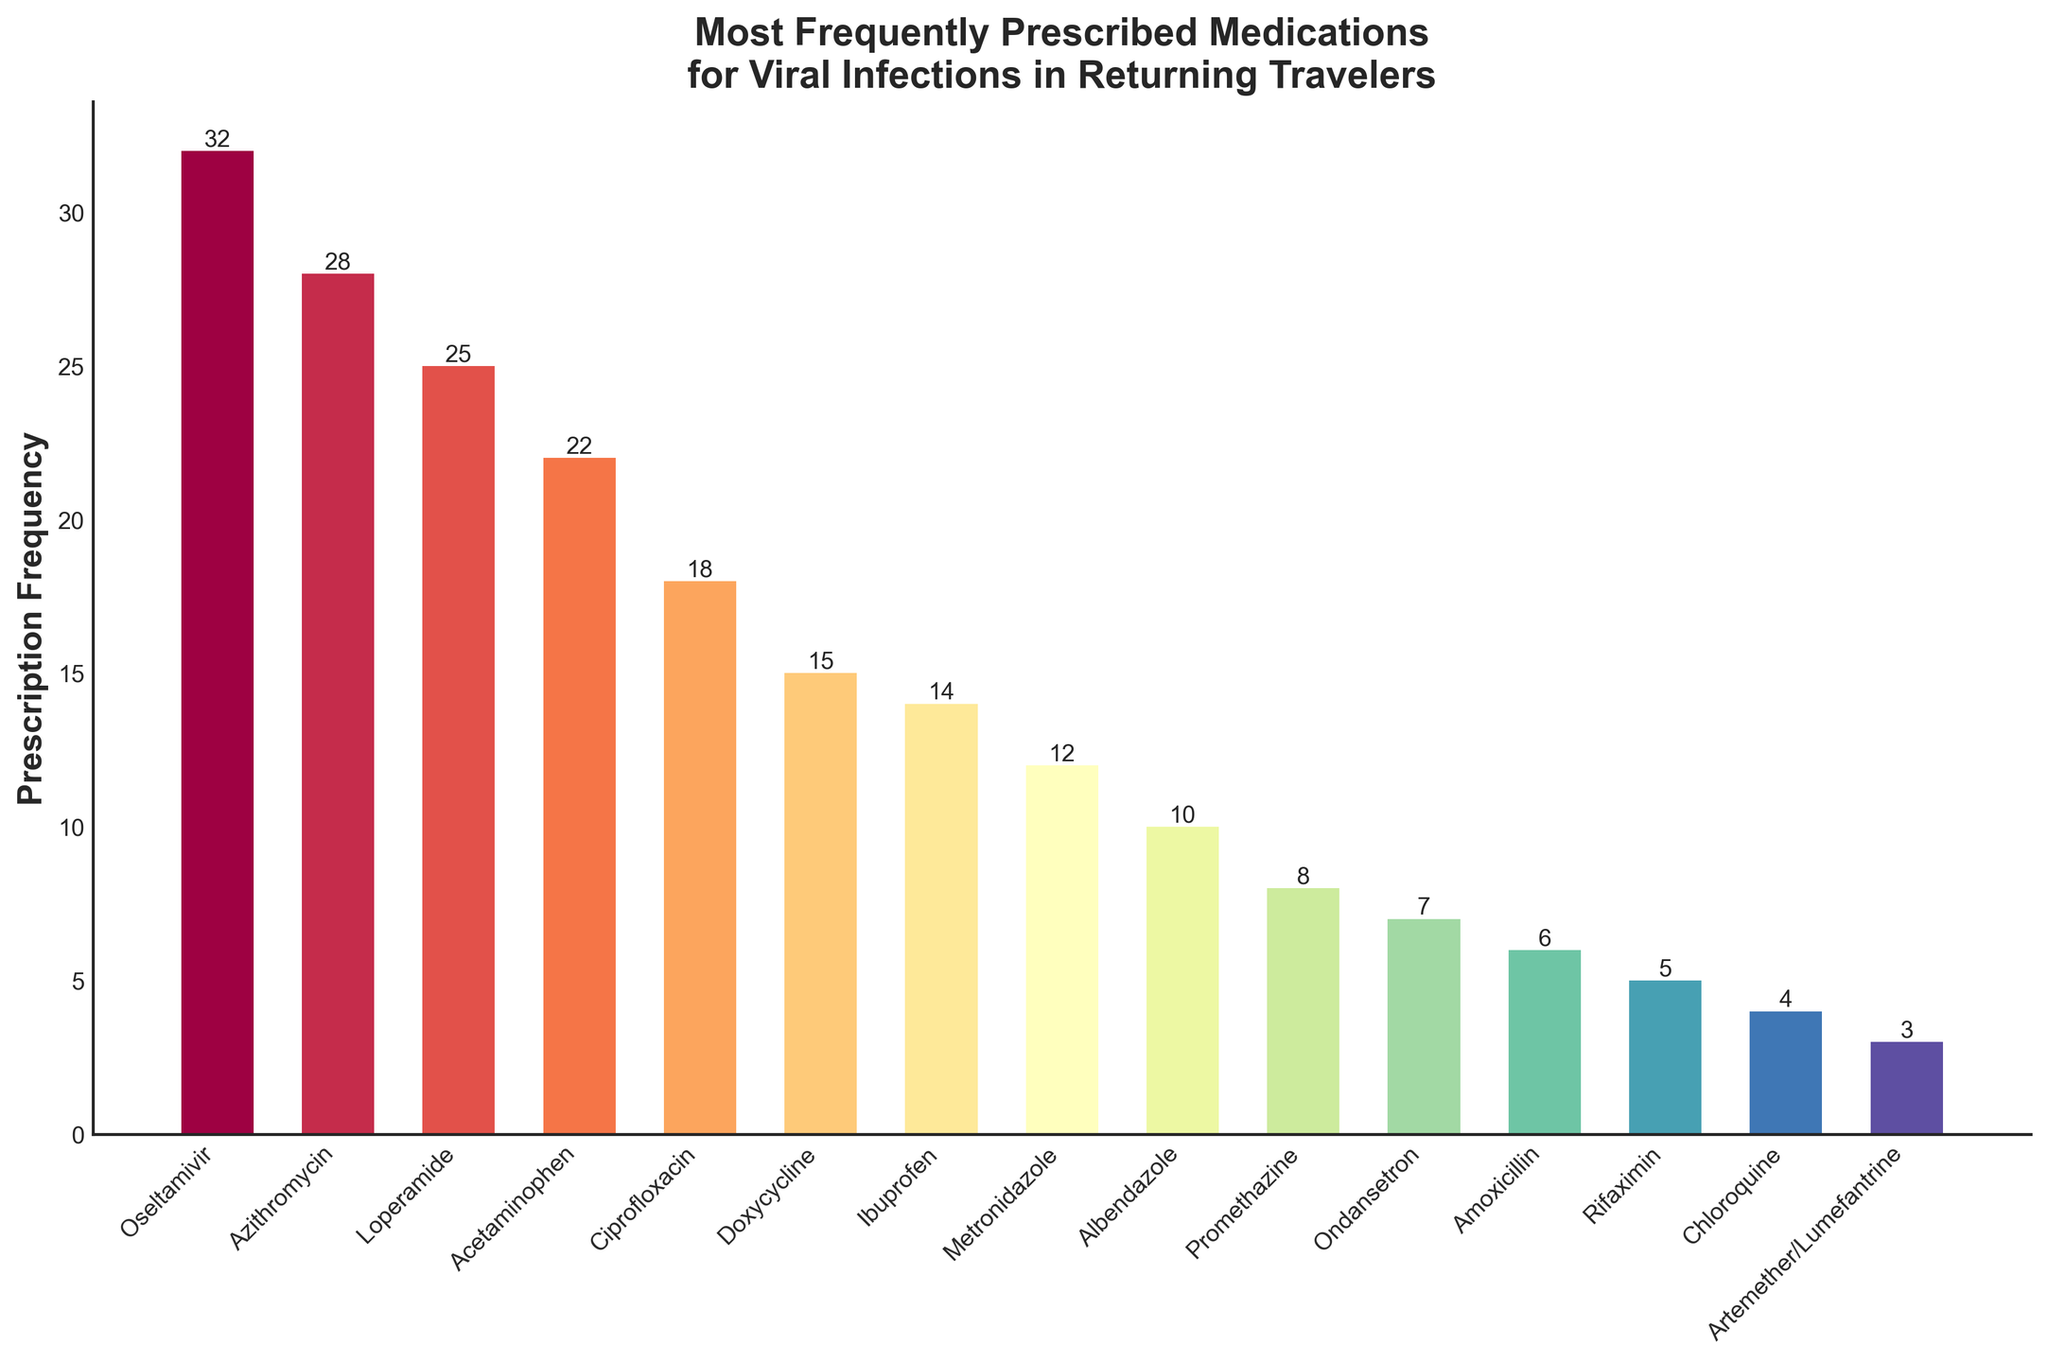Which medication has the highest prescription frequency? Observing the heights of the bars, Oseltamivir has the tallest bar, indicating it has the highest prescription frequency of 32.
Answer: Oseltamivir How many more prescriptions does Oseltamivir have compared to Azithromycin? Oseltamivir has 32 prescriptions and Azithromycin has 28. The difference is 32 - 28 = 4.
Answer: 4 What is the total number of prescriptions for Acetaminophen, Ciprofloxacin, and Doxycycline? Summing up the prescription frequencies: Acetaminophen (22) + Ciprofloxacin (18) + Doxycycline (15) equals 55.
Answer: 55 Which two medications have the smallest prescription frequencies? By examining the height of the bars, Artemether/Lumefantrine (3) and Chloroquine (4) have the smallest frequencies.
Answer: Artemether/Lumefantrine and Chloroquine What is the difference in prescription frequency between Loperamide and Ibuprofen? Loperamide has 25 prescriptions and Ibuprofen has 14. The difference is 25 - 14 = 11.
Answer: 11 Is the prescription frequency of Metronidazole greater than that of Albendazole? Metronidazole has 12 prescriptions while Albendazole has 10. Since 12 > 10, the frequency of Metronidazole is indeed greater.
Answer: Yes Which medication, among Promethazine and Ondansetron, is prescribed more frequently? Promethazine has 8 prescriptions and Ondansetron has 7. Since 8 > 7, Promethazine is prescribed more frequently.
Answer: Promethazine How many medications are prescribed more frequently than Doxycycline? Doxycycline has 15 prescriptions. Counting the number of medications with higher bars: Oseltamivir (32), Azithromycin (28), Loperamide (25), Acetaminophen (22), and Ciprofloxacin (18) makes 5 medications.
Answer: 5 What is the combined prescription frequency of the three least prescribed medications? Artemether/Lumefantrine (3), Chloroquine (4), and Rifaximin (5) add up to 3 + 4 + 5 = 12.
Answer: 12 